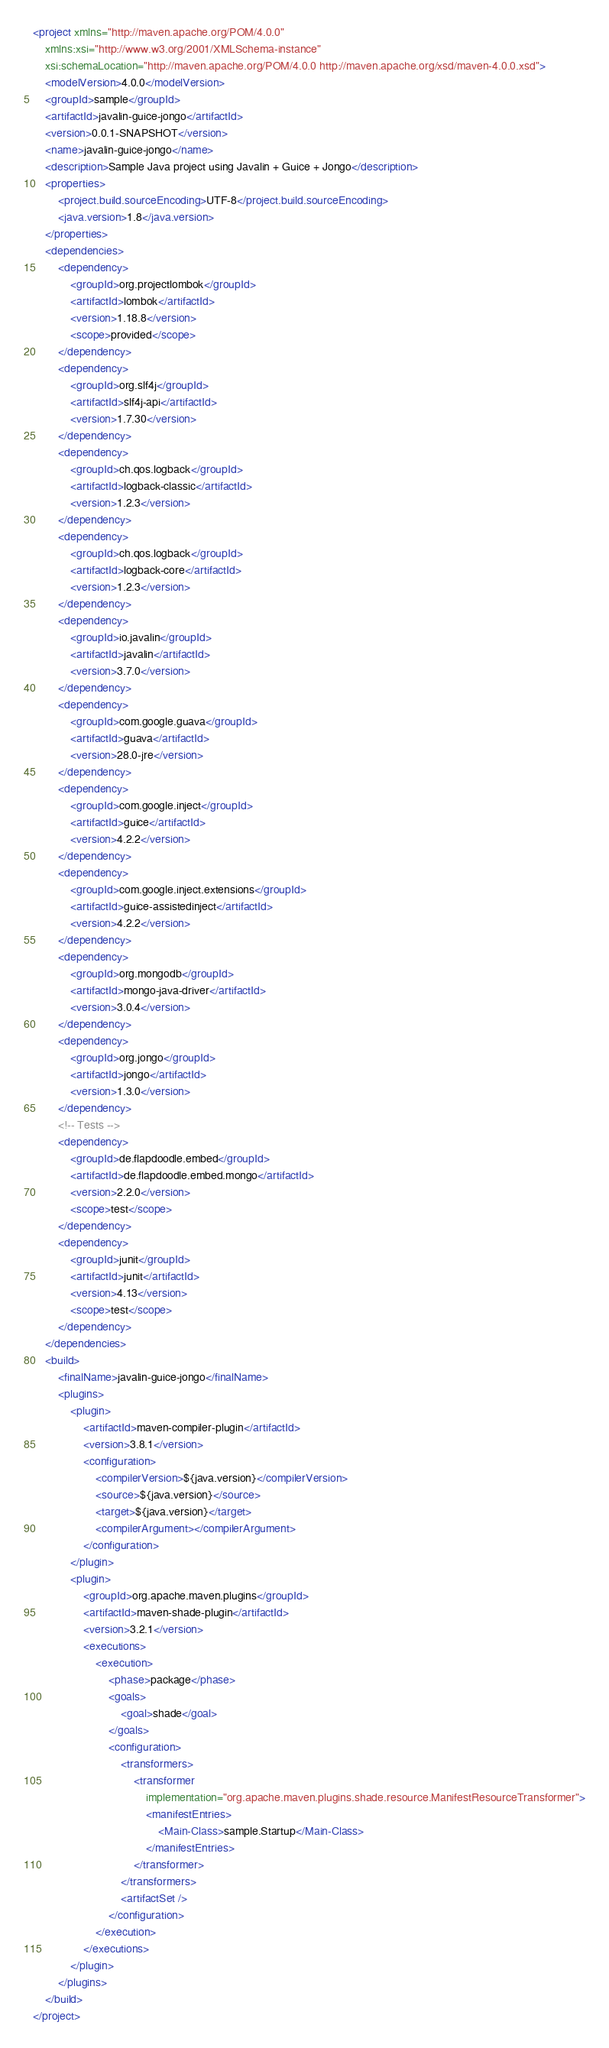Convert code to text. <code><loc_0><loc_0><loc_500><loc_500><_XML_><project xmlns="http://maven.apache.org/POM/4.0.0"
	xmlns:xsi="http://www.w3.org/2001/XMLSchema-instance"
	xsi:schemaLocation="http://maven.apache.org/POM/4.0.0 http://maven.apache.org/xsd/maven-4.0.0.xsd">
	<modelVersion>4.0.0</modelVersion>
	<groupId>sample</groupId>
	<artifactId>javalin-guice-jongo</artifactId>
	<version>0.0.1-SNAPSHOT</version>
	<name>javalin-guice-jongo</name>
	<description>Sample Java project using Javalin + Guice + Jongo</description>
	<properties>
		<project.build.sourceEncoding>UTF-8</project.build.sourceEncoding>
		<java.version>1.8</java.version>
	</properties>
	<dependencies>
		<dependency>
			<groupId>org.projectlombok</groupId>
			<artifactId>lombok</artifactId>
			<version>1.18.8</version>
			<scope>provided</scope>
		</dependency>
		<dependency>
			<groupId>org.slf4j</groupId>
			<artifactId>slf4j-api</artifactId>
			<version>1.7.30</version>
		</dependency>
		<dependency>
			<groupId>ch.qos.logback</groupId>
			<artifactId>logback-classic</artifactId>
			<version>1.2.3</version>
		</dependency>
		<dependency>
			<groupId>ch.qos.logback</groupId>
			<artifactId>logback-core</artifactId>
			<version>1.2.3</version>
		</dependency>
		<dependency>
			<groupId>io.javalin</groupId>
			<artifactId>javalin</artifactId>
			<version>3.7.0</version>
		</dependency>
		<dependency>
			<groupId>com.google.guava</groupId>
			<artifactId>guava</artifactId>
			<version>28.0-jre</version>
		</dependency>
		<dependency>
			<groupId>com.google.inject</groupId>
			<artifactId>guice</artifactId>
			<version>4.2.2</version>
		</dependency>
		<dependency>
			<groupId>com.google.inject.extensions</groupId>
			<artifactId>guice-assistedinject</artifactId>
			<version>4.2.2</version>
		</dependency>
		<dependency>
			<groupId>org.mongodb</groupId>
			<artifactId>mongo-java-driver</artifactId>
			<version>3.0.4</version>
		</dependency>
		<dependency>
			<groupId>org.jongo</groupId>
			<artifactId>jongo</artifactId>
			<version>1.3.0</version>
		</dependency>
		<!-- Tests -->
		<dependency>
			<groupId>de.flapdoodle.embed</groupId>
			<artifactId>de.flapdoodle.embed.mongo</artifactId>
			<version>2.2.0</version>
			<scope>test</scope>
		</dependency>
		<dependency>
			<groupId>junit</groupId>
			<artifactId>junit</artifactId>
			<version>4.13</version>
			<scope>test</scope>
		</dependency>
	</dependencies>
	<build>
		<finalName>javalin-guice-jongo</finalName>
		<plugins>
			<plugin>
				<artifactId>maven-compiler-plugin</artifactId>
				<version>3.8.1</version>
				<configuration>
					<compilerVersion>${java.version}</compilerVersion>
					<source>${java.version}</source>
					<target>${java.version}</target>
					<compilerArgument></compilerArgument>
				</configuration>
			</plugin>
			<plugin>
				<groupId>org.apache.maven.plugins</groupId>
				<artifactId>maven-shade-plugin</artifactId>
				<version>3.2.1</version>
				<executions>
					<execution>
						<phase>package</phase>
						<goals>
							<goal>shade</goal>
						</goals>
						<configuration>
							<transformers>
								<transformer
									implementation="org.apache.maven.plugins.shade.resource.ManifestResourceTransformer">
									<manifestEntries>
										<Main-Class>sample.Startup</Main-Class>
									</manifestEntries>
								</transformer>
							</transformers>
							<artifactSet />
						</configuration>
					</execution>
				</executions>
			</plugin>
		</plugins>
	</build>
</project></code> 